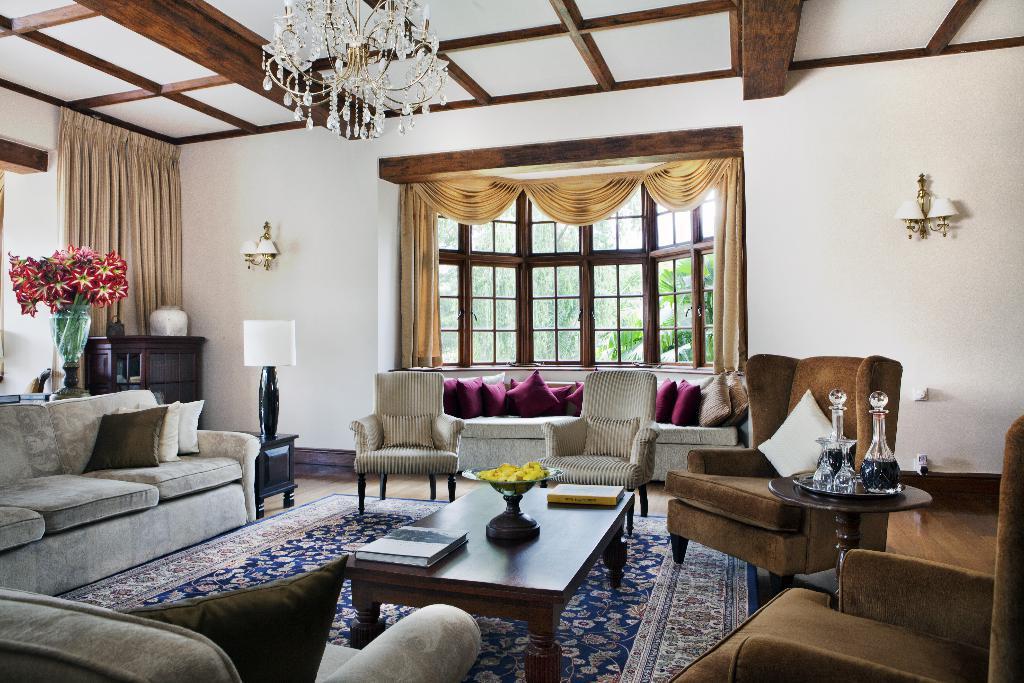Can you describe this image briefly? in this room here is a wall and lamp on it. and on the floor carpet on it ,and here is the table with the flower vase and books on it. and here is flower vase with flowers on it. here is the curtains and at the top roof here is the chandelier, and here is the sofa and pillows on it. 